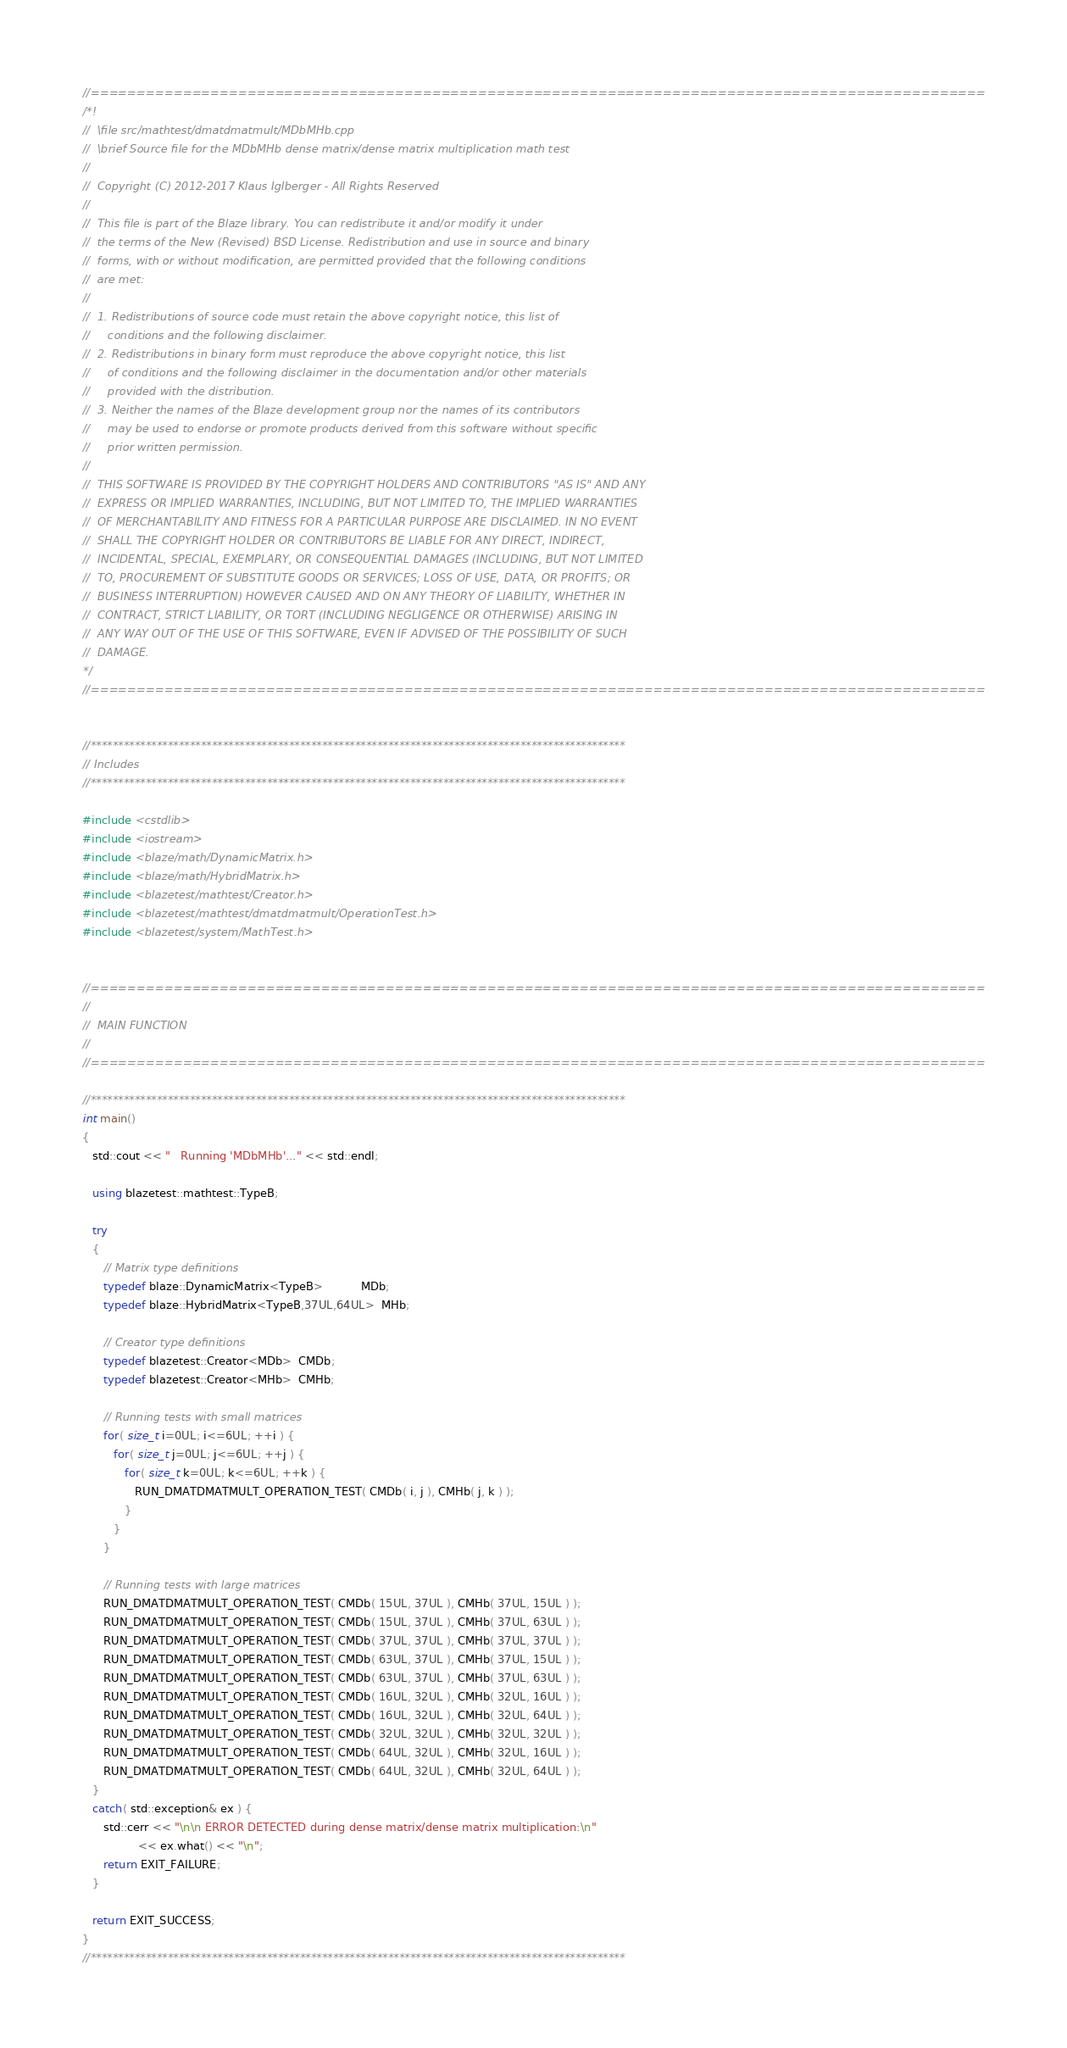Convert code to text. <code><loc_0><loc_0><loc_500><loc_500><_C++_>//=================================================================================================
/*!
//  \file src/mathtest/dmatdmatmult/MDbMHb.cpp
//  \brief Source file for the MDbMHb dense matrix/dense matrix multiplication math test
//
//  Copyright (C) 2012-2017 Klaus Iglberger - All Rights Reserved
//
//  This file is part of the Blaze library. You can redistribute it and/or modify it under
//  the terms of the New (Revised) BSD License. Redistribution and use in source and binary
//  forms, with or without modification, are permitted provided that the following conditions
//  are met:
//
//  1. Redistributions of source code must retain the above copyright notice, this list of
//     conditions and the following disclaimer.
//  2. Redistributions in binary form must reproduce the above copyright notice, this list
//     of conditions and the following disclaimer in the documentation and/or other materials
//     provided with the distribution.
//  3. Neither the names of the Blaze development group nor the names of its contributors
//     may be used to endorse or promote products derived from this software without specific
//     prior written permission.
//
//  THIS SOFTWARE IS PROVIDED BY THE COPYRIGHT HOLDERS AND CONTRIBUTORS "AS IS" AND ANY
//  EXPRESS OR IMPLIED WARRANTIES, INCLUDING, BUT NOT LIMITED TO, THE IMPLIED WARRANTIES
//  OF MERCHANTABILITY AND FITNESS FOR A PARTICULAR PURPOSE ARE DISCLAIMED. IN NO EVENT
//  SHALL THE COPYRIGHT HOLDER OR CONTRIBUTORS BE LIABLE FOR ANY DIRECT, INDIRECT,
//  INCIDENTAL, SPECIAL, EXEMPLARY, OR CONSEQUENTIAL DAMAGES (INCLUDING, BUT NOT LIMITED
//  TO, PROCUREMENT OF SUBSTITUTE GOODS OR SERVICES; LOSS OF USE, DATA, OR PROFITS; OR
//  BUSINESS INTERRUPTION) HOWEVER CAUSED AND ON ANY THEORY OF LIABILITY, WHETHER IN
//  CONTRACT, STRICT LIABILITY, OR TORT (INCLUDING NEGLIGENCE OR OTHERWISE) ARISING IN
//  ANY WAY OUT OF THE USE OF THIS SOFTWARE, EVEN IF ADVISED OF THE POSSIBILITY OF SUCH
//  DAMAGE.
*/
//=================================================================================================


//*************************************************************************************************
// Includes
//*************************************************************************************************

#include <cstdlib>
#include <iostream>
#include <blaze/math/DynamicMatrix.h>
#include <blaze/math/HybridMatrix.h>
#include <blazetest/mathtest/Creator.h>
#include <blazetest/mathtest/dmatdmatmult/OperationTest.h>
#include <blazetest/system/MathTest.h>


//=================================================================================================
//
//  MAIN FUNCTION
//
//=================================================================================================

//*************************************************************************************************
int main()
{
   std::cout << "   Running 'MDbMHb'..." << std::endl;

   using blazetest::mathtest::TypeB;

   try
   {
      // Matrix type definitions
      typedef blaze::DynamicMatrix<TypeB>           MDb;
      typedef blaze::HybridMatrix<TypeB,37UL,64UL>  MHb;

      // Creator type definitions
      typedef blazetest::Creator<MDb>  CMDb;
      typedef blazetest::Creator<MHb>  CMHb;

      // Running tests with small matrices
      for( size_t i=0UL; i<=6UL; ++i ) {
         for( size_t j=0UL; j<=6UL; ++j ) {
            for( size_t k=0UL; k<=6UL; ++k ) {
               RUN_DMATDMATMULT_OPERATION_TEST( CMDb( i, j ), CMHb( j, k ) );
            }
         }
      }

      // Running tests with large matrices
      RUN_DMATDMATMULT_OPERATION_TEST( CMDb( 15UL, 37UL ), CMHb( 37UL, 15UL ) );
      RUN_DMATDMATMULT_OPERATION_TEST( CMDb( 15UL, 37UL ), CMHb( 37UL, 63UL ) );
      RUN_DMATDMATMULT_OPERATION_TEST( CMDb( 37UL, 37UL ), CMHb( 37UL, 37UL ) );
      RUN_DMATDMATMULT_OPERATION_TEST( CMDb( 63UL, 37UL ), CMHb( 37UL, 15UL ) );
      RUN_DMATDMATMULT_OPERATION_TEST( CMDb( 63UL, 37UL ), CMHb( 37UL, 63UL ) );
      RUN_DMATDMATMULT_OPERATION_TEST( CMDb( 16UL, 32UL ), CMHb( 32UL, 16UL ) );
      RUN_DMATDMATMULT_OPERATION_TEST( CMDb( 16UL, 32UL ), CMHb( 32UL, 64UL ) );
      RUN_DMATDMATMULT_OPERATION_TEST( CMDb( 32UL, 32UL ), CMHb( 32UL, 32UL ) );
      RUN_DMATDMATMULT_OPERATION_TEST( CMDb( 64UL, 32UL ), CMHb( 32UL, 16UL ) );
      RUN_DMATDMATMULT_OPERATION_TEST( CMDb( 64UL, 32UL ), CMHb( 32UL, 64UL ) );
   }
   catch( std::exception& ex ) {
      std::cerr << "\n\n ERROR DETECTED during dense matrix/dense matrix multiplication:\n"
                << ex.what() << "\n";
      return EXIT_FAILURE;
   }

   return EXIT_SUCCESS;
}
//*************************************************************************************************
</code> 